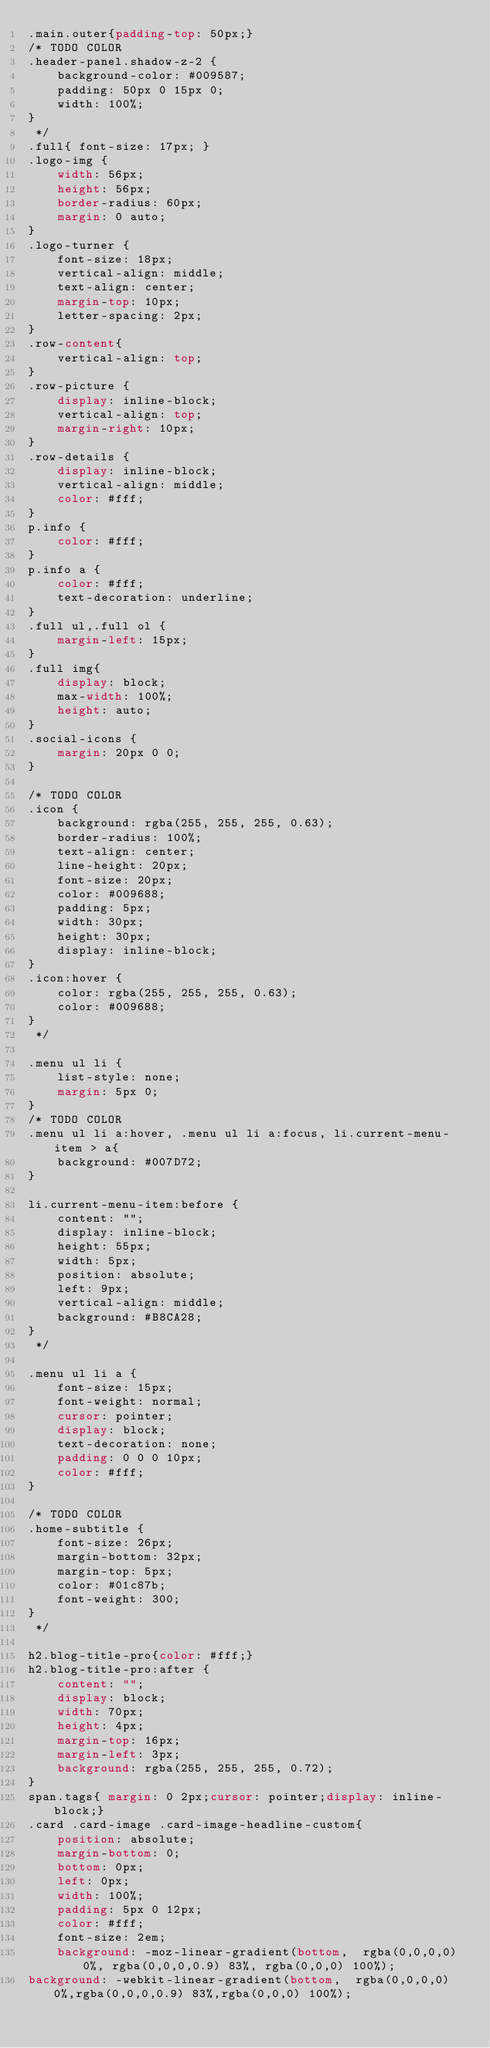Convert code to text. <code><loc_0><loc_0><loc_500><loc_500><_CSS_>.main.outer{padding-top: 50px;}
/* TODO COLOR
.header-panel.shadow-z-2 {
    background-color: #009587;
    padding: 50px 0 15px 0;
    width: 100%;
}
 */
.full{ font-size: 17px; }
.logo-img {
    width: 56px;
    height: 56px;
    border-radius: 60px;
    margin: 0 auto;
}
.logo-turner {
    font-size: 18px;
    vertical-align: middle;
    text-align: center;
    margin-top: 10px;
    letter-spacing: 2px;
}
.row-content{
    vertical-align: top;
}
.row-picture {
    display: inline-block;
    vertical-align: top;
    margin-right: 10px;
}
.row-details {
    display: inline-block;
    vertical-align: middle;
    color: #fff;
}
p.info {
    color: #fff;
}
p.info a {
    color: #fff;
    text-decoration: underline;
}
.full ul,.full ol {
    margin-left: 15px;
}
.full img{
    display: block;
    max-width: 100%;
    height: auto;
}
.social-icons {
    margin: 20px 0 0;
}

/* TODO COLOR
.icon {
    background: rgba(255, 255, 255, 0.63);
    border-radius: 100%;
    text-align: center;
    line-height: 20px;
    font-size: 20px;
    color: #009688;
    padding: 5px;
    width: 30px;
    height: 30px;
    display: inline-block;
}
.icon:hover {
    color: rgba(255, 255, 255, 0.63);
    color: #009688;
} 
 */

.menu ul li {
    list-style: none;
    margin: 5px 0;
}
/* TODO COLOR
.menu ul li a:hover, .menu ul li a:focus, li.current-menu-item > a{
    background: #007D72;
}

li.current-menu-item:before {
    content: "";
    display: inline-block;
    height: 55px;
    width: 5px;
    position: absolute;
    left: 9px;
    vertical-align: middle;
    background: #B8CA28;
}
 */

.menu ul li a {
    font-size: 15px;
    font-weight: normal;
    cursor: pointer;
    display: block;
    text-decoration: none;
    padding: 0 0 0 10px;
    color: #fff;
}

/* TODO COLOR
.home-subtitle {
    font-size: 26px;
    margin-bottom: 32px;
    margin-top: 5px;
    color: #01c87b;
    font-weight: 300;
}
 */

h2.blog-title-pro{color: #fff;}
h2.blog-title-pro:after {
    content: "";
    display: block;
    width: 70px;
    height: 4px;
    margin-top: 16px;
    margin-left: 3px;
    background: rgba(255, 255, 255, 0.72);
}
span.tags{ margin: 0 2px;cursor: pointer;display: inline-block;}
.card .card-image .card-image-headline-custom{
    position: absolute;
    margin-bottom: 0;
    bottom: 0px;
    left: 0px;
    width: 100%;
    padding: 5px 0 12px;
    color: #fff;
    font-size: 2em;
    background: -moz-linear-gradient(bottom,  rgba(0,0,0,0) 0%, rgba(0,0,0,0.9) 83%, rgba(0,0,0) 100%);
background: -webkit-linear-gradient(bottom,  rgba(0,0,0,0) 0%,rgba(0,0,0,0.9) 83%,rgba(0,0,0) 100%);</code> 